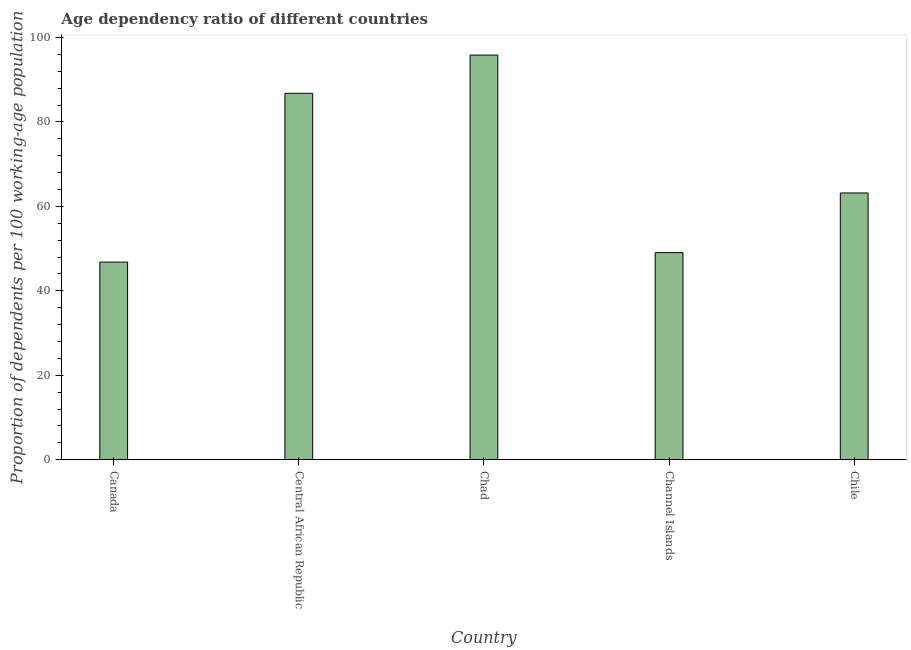Does the graph contain grids?
Your answer should be very brief. No. What is the title of the graph?
Your answer should be very brief. Age dependency ratio of different countries. What is the label or title of the X-axis?
Make the answer very short. Country. What is the label or title of the Y-axis?
Your answer should be compact. Proportion of dependents per 100 working-age population. What is the age dependency ratio in Central African Republic?
Your response must be concise. 86.77. Across all countries, what is the maximum age dependency ratio?
Keep it short and to the point. 95.82. Across all countries, what is the minimum age dependency ratio?
Keep it short and to the point. 46.79. In which country was the age dependency ratio maximum?
Make the answer very short. Chad. In which country was the age dependency ratio minimum?
Make the answer very short. Canada. What is the sum of the age dependency ratio?
Offer a terse response. 341.59. What is the difference between the age dependency ratio in Central African Republic and Chad?
Your answer should be very brief. -9.05. What is the average age dependency ratio per country?
Your response must be concise. 68.32. What is the median age dependency ratio?
Keep it short and to the point. 63.17. What is the ratio of the age dependency ratio in Channel Islands to that in Chile?
Your response must be concise. 0.78. Is the age dependency ratio in Canada less than that in Chad?
Keep it short and to the point. Yes. Is the difference between the age dependency ratio in Chad and Channel Islands greater than the difference between any two countries?
Give a very brief answer. No. What is the difference between the highest and the second highest age dependency ratio?
Your answer should be very brief. 9.05. Is the sum of the age dependency ratio in Channel Islands and Chile greater than the maximum age dependency ratio across all countries?
Your answer should be compact. Yes. What is the difference between the highest and the lowest age dependency ratio?
Your response must be concise. 49.03. How many bars are there?
Your answer should be very brief. 5. How many countries are there in the graph?
Your response must be concise. 5. Are the values on the major ticks of Y-axis written in scientific E-notation?
Your response must be concise. No. What is the Proportion of dependents per 100 working-age population in Canada?
Offer a terse response. 46.79. What is the Proportion of dependents per 100 working-age population in Central African Republic?
Your answer should be compact. 86.77. What is the Proportion of dependents per 100 working-age population in Chad?
Make the answer very short. 95.82. What is the Proportion of dependents per 100 working-age population in Channel Islands?
Keep it short and to the point. 49.04. What is the Proportion of dependents per 100 working-age population of Chile?
Give a very brief answer. 63.17. What is the difference between the Proportion of dependents per 100 working-age population in Canada and Central African Republic?
Ensure brevity in your answer.  -39.97. What is the difference between the Proportion of dependents per 100 working-age population in Canada and Chad?
Your answer should be very brief. -49.03. What is the difference between the Proportion of dependents per 100 working-age population in Canada and Channel Islands?
Ensure brevity in your answer.  -2.25. What is the difference between the Proportion of dependents per 100 working-age population in Canada and Chile?
Offer a very short reply. -16.38. What is the difference between the Proportion of dependents per 100 working-age population in Central African Republic and Chad?
Your answer should be compact. -9.05. What is the difference between the Proportion of dependents per 100 working-age population in Central African Republic and Channel Islands?
Ensure brevity in your answer.  37.73. What is the difference between the Proportion of dependents per 100 working-age population in Central African Republic and Chile?
Keep it short and to the point. 23.59. What is the difference between the Proportion of dependents per 100 working-age population in Chad and Channel Islands?
Provide a succinct answer. 46.78. What is the difference between the Proportion of dependents per 100 working-age population in Chad and Chile?
Ensure brevity in your answer.  32.65. What is the difference between the Proportion of dependents per 100 working-age population in Channel Islands and Chile?
Make the answer very short. -14.13. What is the ratio of the Proportion of dependents per 100 working-age population in Canada to that in Central African Republic?
Your answer should be compact. 0.54. What is the ratio of the Proportion of dependents per 100 working-age population in Canada to that in Chad?
Provide a succinct answer. 0.49. What is the ratio of the Proportion of dependents per 100 working-age population in Canada to that in Channel Islands?
Your answer should be very brief. 0.95. What is the ratio of the Proportion of dependents per 100 working-age population in Canada to that in Chile?
Make the answer very short. 0.74. What is the ratio of the Proportion of dependents per 100 working-age population in Central African Republic to that in Chad?
Ensure brevity in your answer.  0.91. What is the ratio of the Proportion of dependents per 100 working-age population in Central African Republic to that in Channel Islands?
Give a very brief answer. 1.77. What is the ratio of the Proportion of dependents per 100 working-age population in Central African Republic to that in Chile?
Make the answer very short. 1.37. What is the ratio of the Proportion of dependents per 100 working-age population in Chad to that in Channel Islands?
Make the answer very short. 1.95. What is the ratio of the Proportion of dependents per 100 working-age population in Chad to that in Chile?
Give a very brief answer. 1.52. What is the ratio of the Proportion of dependents per 100 working-age population in Channel Islands to that in Chile?
Provide a succinct answer. 0.78. 